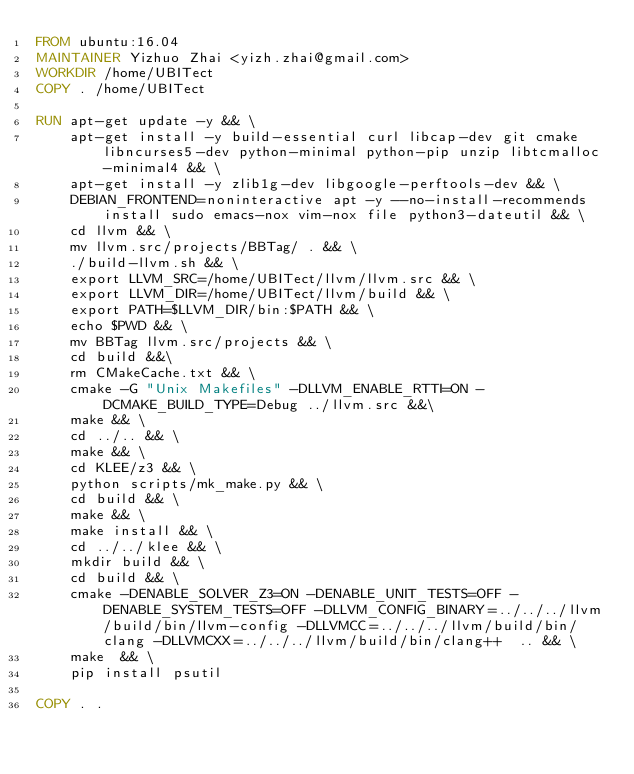<code> <loc_0><loc_0><loc_500><loc_500><_Dockerfile_>FROM ubuntu:16.04
MAINTAINER Yizhuo Zhai <yizh.zhai@gmail.com>
WORKDIR /home/UBITect
COPY . /home/UBITect

RUN apt-get update -y && \
    apt-get install -y build-essential curl libcap-dev git cmake libncurses5-dev python-minimal python-pip unzip libtcmalloc-minimal4 && \
    apt-get install -y zlib1g-dev libgoogle-perftools-dev && \
    DEBIAN_FRONTEND=noninteractive apt -y --no-install-recommends install sudo emacs-nox vim-nox file python3-dateutil && \
    cd llvm && \
    mv llvm.src/projects/BBTag/ . && \
    ./build-llvm.sh && \
    export LLVM_SRC=/home/UBITect/llvm/llvm.src && \
    export LLVM_DIR=/home/UBITect/llvm/build && \
    export PATH=$LLVM_DIR/bin:$PATH && \
    echo $PWD && \
    mv BBTag llvm.src/projects && \
    cd build &&\
    rm CMakeCache.txt && \
    cmake -G "Unix Makefiles" -DLLVM_ENABLE_RTTI=ON -DCMAKE_BUILD_TYPE=Debug ../llvm.src &&\
    make && \
    cd ../.. && \
    make && \
    cd KLEE/z3 && \
    python scripts/mk_make.py && \
    cd build && \
    make && \
    make install && \
    cd ../../klee && \
    mkdir build && \
    cd build && \
    cmake -DENABLE_SOLVER_Z3=ON -DENABLE_UNIT_TESTS=OFF -DENABLE_SYSTEM_TESTS=OFF -DLLVM_CONFIG_BINARY=../../../llvm/build/bin/llvm-config -DLLVMCC=../../../llvm/build/bin/clang -DLLVMCXX=../../../llvm/build/bin/clang++  .. && \
    make  && \
    pip install psutil

COPY . .
</code> 